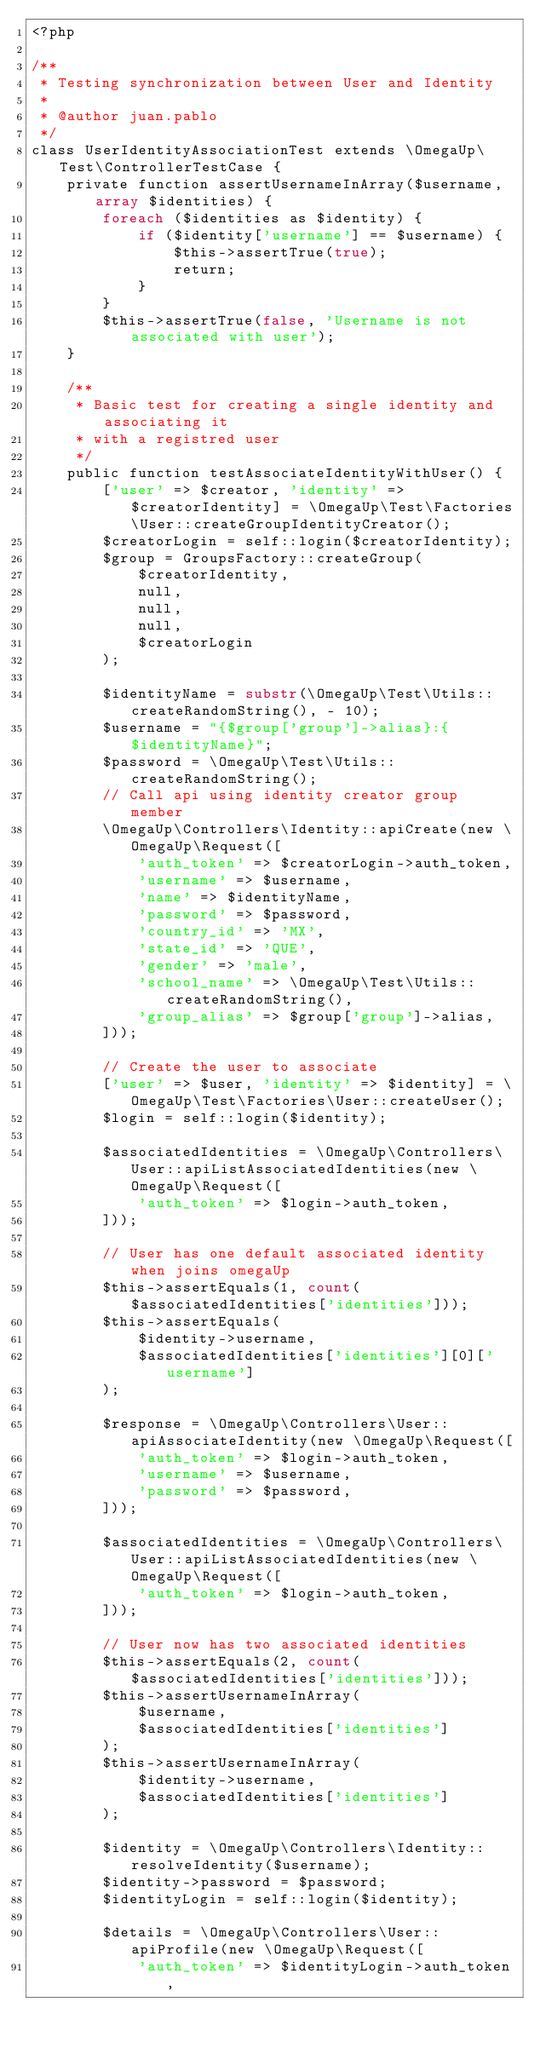<code> <loc_0><loc_0><loc_500><loc_500><_PHP_><?php

/**
 * Testing synchronization between User and Identity
 *
 * @author juan.pablo
 */
class UserIdentityAssociationTest extends \OmegaUp\Test\ControllerTestCase {
    private function assertUsernameInArray($username, array $identities) {
        foreach ($identities as $identity) {
            if ($identity['username'] == $username) {
                $this->assertTrue(true);
                return;
            }
        }
        $this->assertTrue(false, 'Username is not associated with user');
    }

    /**
     * Basic test for creating a single identity and associating it
     * with a registred user
     */
    public function testAssociateIdentityWithUser() {
        ['user' => $creator, 'identity' => $creatorIdentity] = \OmegaUp\Test\Factories\User::createGroupIdentityCreator();
        $creatorLogin = self::login($creatorIdentity);
        $group = GroupsFactory::createGroup(
            $creatorIdentity,
            null,
            null,
            null,
            $creatorLogin
        );

        $identityName = substr(\OmegaUp\Test\Utils::createRandomString(), - 10);
        $username = "{$group['group']->alias}:{$identityName}";
        $password = \OmegaUp\Test\Utils::createRandomString();
        // Call api using identity creator group member
        \OmegaUp\Controllers\Identity::apiCreate(new \OmegaUp\Request([
            'auth_token' => $creatorLogin->auth_token,
            'username' => $username,
            'name' => $identityName,
            'password' => $password,
            'country_id' => 'MX',
            'state_id' => 'QUE',
            'gender' => 'male',
            'school_name' => \OmegaUp\Test\Utils::createRandomString(),
            'group_alias' => $group['group']->alias,
        ]));

        // Create the user to associate
        ['user' => $user, 'identity' => $identity] = \OmegaUp\Test\Factories\User::createUser();
        $login = self::login($identity);

        $associatedIdentities = \OmegaUp\Controllers\User::apiListAssociatedIdentities(new \OmegaUp\Request([
            'auth_token' => $login->auth_token,
        ]));

        // User has one default associated identity when joins omegaUp
        $this->assertEquals(1, count($associatedIdentities['identities']));
        $this->assertEquals(
            $identity->username,
            $associatedIdentities['identities'][0]['username']
        );

        $response = \OmegaUp\Controllers\User::apiAssociateIdentity(new \OmegaUp\Request([
            'auth_token' => $login->auth_token,
            'username' => $username,
            'password' => $password,
        ]));

        $associatedIdentities = \OmegaUp\Controllers\User::apiListAssociatedIdentities(new \OmegaUp\Request([
            'auth_token' => $login->auth_token,
        ]));

        // User now has two associated identities
        $this->assertEquals(2, count($associatedIdentities['identities']));
        $this->assertUsernameInArray(
            $username,
            $associatedIdentities['identities']
        );
        $this->assertUsernameInArray(
            $identity->username,
            $associatedIdentities['identities']
        );

        $identity = \OmegaUp\Controllers\Identity::resolveIdentity($username);
        $identity->password = $password;
        $identityLogin = self::login($identity);

        $details = \OmegaUp\Controllers\User::apiProfile(new \OmegaUp\Request([
            'auth_token' => $identityLogin->auth_token,</code> 